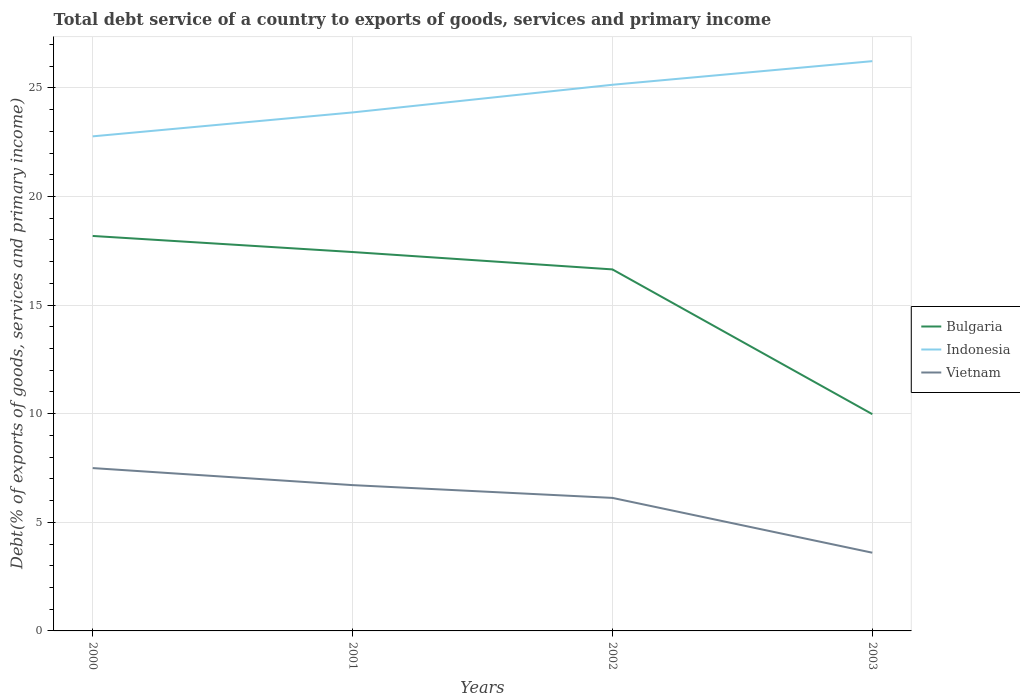How many different coloured lines are there?
Provide a succinct answer. 3. Across all years, what is the maximum total debt service in Vietnam?
Your answer should be very brief. 3.6. In which year was the total debt service in Bulgaria maximum?
Your answer should be very brief. 2003. What is the total total debt service in Vietnam in the graph?
Provide a short and direct response. 2.52. What is the difference between the highest and the second highest total debt service in Vietnam?
Give a very brief answer. 3.9. Is the total debt service in Bulgaria strictly greater than the total debt service in Vietnam over the years?
Provide a succinct answer. No. How many lines are there?
Make the answer very short. 3. How many years are there in the graph?
Your answer should be compact. 4. Are the values on the major ticks of Y-axis written in scientific E-notation?
Ensure brevity in your answer.  No. How many legend labels are there?
Offer a terse response. 3. How are the legend labels stacked?
Ensure brevity in your answer.  Vertical. What is the title of the graph?
Your answer should be compact. Total debt service of a country to exports of goods, services and primary income. Does "Gambia, The" appear as one of the legend labels in the graph?
Your response must be concise. No. What is the label or title of the X-axis?
Offer a terse response. Years. What is the label or title of the Y-axis?
Make the answer very short. Debt(% of exports of goods, services and primary income). What is the Debt(% of exports of goods, services and primary income) in Bulgaria in 2000?
Your answer should be compact. 18.18. What is the Debt(% of exports of goods, services and primary income) of Indonesia in 2000?
Your response must be concise. 22.77. What is the Debt(% of exports of goods, services and primary income) in Vietnam in 2000?
Make the answer very short. 7.5. What is the Debt(% of exports of goods, services and primary income) in Bulgaria in 2001?
Give a very brief answer. 17.44. What is the Debt(% of exports of goods, services and primary income) in Indonesia in 2001?
Keep it short and to the point. 23.87. What is the Debt(% of exports of goods, services and primary income) in Vietnam in 2001?
Your answer should be very brief. 6.71. What is the Debt(% of exports of goods, services and primary income) of Bulgaria in 2002?
Make the answer very short. 16.64. What is the Debt(% of exports of goods, services and primary income) in Indonesia in 2002?
Your answer should be compact. 25.14. What is the Debt(% of exports of goods, services and primary income) in Vietnam in 2002?
Your answer should be compact. 6.12. What is the Debt(% of exports of goods, services and primary income) in Bulgaria in 2003?
Ensure brevity in your answer.  9.98. What is the Debt(% of exports of goods, services and primary income) of Indonesia in 2003?
Your response must be concise. 26.23. What is the Debt(% of exports of goods, services and primary income) in Vietnam in 2003?
Keep it short and to the point. 3.6. Across all years, what is the maximum Debt(% of exports of goods, services and primary income) in Bulgaria?
Offer a very short reply. 18.18. Across all years, what is the maximum Debt(% of exports of goods, services and primary income) of Indonesia?
Your answer should be very brief. 26.23. Across all years, what is the maximum Debt(% of exports of goods, services and primary income) in Vietnam?
Your response must be concise. 7.5. Across all years, what is the minimum Debt(% of exports of goods, services and primary income) in Bulgaria?
Make the answer very short. 9.98. Across all years, what is the minimum Debt(% of exports of goods, services and primary income) of Indonesia?
Your answer should be very brief. 22.77. Across all years, what is the minimum Debt(% of exports of goods, services and primary income) of Vietnam?
Your response must be concise. 3.6. What is the total Debt(% of exports of goods, services and primary income) in Bulgaria in the graph?
Your answer should be compact. 62.24. What is the total Debt(% of exports of goods, services and primary income) of Indonesia in the graph?
Your answer should be compact. 98. What is the total Debt(% of exports of goods, services and primary income) of Vietnam in the graph?
Your answer should be compact. 23.93. What is the difference between the Debt(% of exports of goods, services and primary income) in Bulgaria in 2000 and that in 2001?
Your response must be concise. 0.74. What is the difference between the Debt(% of exports of goods, services and primary income) of Indonesia in 2000 and that in 2001?
Your answer should be very brief. -1.1. What is the difference between the Debt(% of exports of goods, services and primary income) in Vietnam in 2000 and that in 2001?
Keep it short and to the point. 0.78. What is the difference between the Debt(% of exports of goods, services and primary income) in Bulgaria in 2000 and that in 2002?
Keep it short and to the point. 1.54. What is the difference between the Debt(% of exports of goods, services and primary income) in Indonesia in 2000 and that in 2002?
Give a very brief answer. -2.38. What is the difference between the Debt(% of exports of goods, services and primary income) of Vietnam in 2000 and that in 2002?
Make the answer very short. 1.37. What is the difference between the Debt(% of exports of goods, services and primary income) in Bulgaria in 2000 and that in 2003?
Keep it short and to the point. 8.2. What is the difference between the Debt(% of exports of goods, services and primary income) in Indonesia in 2000 and that in 2003?
Give a very brief answer. -3.46. What is the difference between the Debt(% of exports of goods, services and primary income) of Vietnam in 2000 and that in 2003?
Make the answer very short. 3.9. What is the difference between the Debt(% of exports of goods, services and primary income) of Bulgaria in 2001 and that in 2002?
Offer a terse response. 0.8. What is the difference between the Debt(% of exports of goods, services and primary income) of Indonesia in 2001 and that in 2002?
Provide a succinct answer. -1.27. What is the difference between the Debt(% of exports of goods, services and primary income) in Vietnam in 2001 and that in 2002?
Your response must be concise. 0.59. What is the difference between the Debt(% of exports of goods, services and primary income) of Bulgaria in 2001 and that in 2003?
Provide a short and direct response. 7.46. What is the difference between the Debt(% of exports of goods, services and primary income) in Indonesia in 2001 and that in 2003?
Your answer should be compact. -2.36. What is the difference between the Debt(% of exports of goods, services and primary income) of Vietnam in 2001 and that in 2003?
Your answer should be compact. 3.11. What is the difference between the Debt(% of exports of goods, services and primary income) in Bulgaria in 2002 and that in 2003?
Ensure brevity in your answer.  6.66. What is the difference between the Debt(% of exports of goods, services and primary income) of Indonesia in 2002 and that in 2003?
Your answer should be compact. -1.09. What is the difference between the Debt(% of exports of goods, services and primary income) of Vietnam in 2002 and that in 2003?
Ensure brevity in your answer.  2.52. What is the difference between the Debt(% of exports of goods, services and primary income) of Bulgaria in 2000 and the Debt(% of exports of goods, services and primary income) of Indonesia in 2001?
Offer a terse response. -5.69. What is the difference between the Debt(% of exports of goods, services and primary income) in Bulgaria in 2000 and the Debt(% of exports of goods, services and primary income) in Vietnam in 2001?
Give a very brief answer. 11.47. What is the difference between the Debt(% of exports of goods, services and primary income) of Indonesia in 2000 and the Debt(% of exports of goods, services and primary income) of Vietnam in 2001?
Offer a very short reply. 16.05. What is the difference between the Debt(% of exports of goods, services and primary income) in Bulgaria in 2000 and the Debt(% of exports of goods, services and primary income) in Indonesia in 2002?
Provide a succinct answer. -6.96. What is the difference between the Debt(% of exports of goods, services and primary income) in Bulgaria in 2000 and the Debt(% of exports of goods, services and primary income) in Vietnam in 2002?
Your answer should be compact. 12.06. What is the difference between the Debt(% of exports of goods, services and primary income) in Indonesia in 2000 and the Debt(% of exports of goods, services and primary income) in Vietnam in 2002?
Make the answer very short. 16.64. What is the difference between the Debt(% of exports of goods, services and primary income) of Bulgaria in 2000 and the Debt(% of exports of goods, services and primary income) of Indonesia in 2003?
Provide a short and direct response. -8.05. What is the difference between the Debt(% of exports of goods, services and primary income) in Bulgaria in 2000 and the Debt(% of exports of goods, services and primary income) in Vietnam in 2003?
Make the answer very short. 14.58. What is the difference between the Debt(% of exports of goods, services and primary income) of Indonesia in 2000 and the Debt(% of exports of goods, services and primary income) of Vietnam in 2003?
Provide a short and direct response. 19.17. What is the difference between the Debt(% of exports of goods, services and primary income) in Bulgaria in 2001 and the Debt(% of exports of goods, services and primary income) in Indonesia in 2002?
Give a very brief answer. -7.7. What is the difference between the Debt(% of exports of goods, services and primary income) in Bulgaria in 2001 and the Debt(% of exports of goods, services and primary income) in Vietnam in 2002?
Keep it short and to the point. 11.32. What is the difference between the Debt(% of exports of goods, services and primary income) in Indonesia in 2001 and the Debt(% of exports of goods, services and primary income) in Vietnam in 2002?
Provide a short and direct response. 17.74. What is the difference between the Debt(% of exports of goods, services and primary income) in Bulgaria in 2001 and the Debt(% of exports of goods, services and primary income) in Indonesia in 2003?
Make the answer very short. -8.79. What is the difference between the Debt(% of exports of goods, services and primary income) of Bulgaria in 2001 and the Debt(% of exports of goods, services and primary income) of Vietnam in 2003?
Your response must be concise. 13.84. What is the difference between the Debt(% of exports of goods, services and primary income) of Indonesia in 2001 and the Debt(% of exports of goods, services and primary income) of Vietnam in 2003?
Provide a succinct answer. 20.27. What is the difference between the Debt(% of exports of goods, services and primary income) in Bulgaria in 2002 and the Debt(% of exports of goods, services and primary income) in Indonesia in 2003?
Offer a very short reply. -9.59. What is the difference between the Debt(% of exports of goods, services and primary income) of Bulgaria in 2002 and the Debt(% of exports of goods, services and primary income) of Vietnam in 2003?
Keep it short and to the point. 13.04. What is the difference between the Debt(% of exports of goods, services and primary income) of Indonesia in 2002 and the Debt(% of exports of goods, services and primary income) of Vietnam in 2003?
Provide a short and direct response. 21.54. What is the average Debt(% of exports of goods, services and primary income) in Bulgaria per year?
Offer a very short reply. 15.56. What is the average Debt(% of exports of goods, services and primary income) in Indonesia per year?
Keep it short and to the point. 24.5. What is the average Debt(% of exports of goods, services and primary income) of Vietnam per year?
Give a very brief answer. 5.98. In the year 2000, what is the difference between the Debt(% of exports of goods, services and primary income) in Bulgaria and Debt(% of exports of goods, services and primary income) in Indonesia?
Your answer should be compact. -4.58. In the year 2000, what is the difference between the Debt(% of exports of goods, services and primary income) of Bulgaria and Debt(% of exports of goods, services and primary income) of Vietnam?
Provide a succinct answer. 10.69. In the year 2000, what is the difference between the Debt(% of exports of goods, services and primary income) in Indonesia and Debt(% of exports of goods, services and primary income) in Vietnam?
Provide a succinct answer. 15.27. In the year 2001, what is the difference between the Debt(% of exports of goods, services and primary income) of Bulgaria and Debt(% of exports of goods, services and primary income) of Indonesia?
Your answer should be compact. -6.43. In the year 2001, what is the difference between the Debt(% of exports of goods, services and primary income) of Bulgaria and Debt(% of exports of goods, services and primary income) of Vietnam?
Keep it short and to the point. 10.73. In the year 2001, what is the difference between the Debt(% of exports of goods, services and primary income) in Indonesia and Debt(% of exports of goods, services and primary income) in Vietnam?
Ensure brevity in your answer.  17.16. In the year 2002, what is the difference between the Debt(% of exports of goods, services and primary income) of Bulgaria and Debt(% of exports of goods, services and primary income) of Vietnam?
Keep it short and to the point. 10.52. In the year 2002, what is the difference between the Debt(% of exports of goods, services and primary income) of Indonesia and Debt(% of exports of goods, services and primary income) of Vietnam?
Offer a terse response. 19.02. In the year 2003, what is the difference between the Debt(% of exports of goods, services and primary income) in Bulgaria and Debt(% of exports of goods, services and primary income) in Indonesia?
Your answer should be very brief. -16.25. In the year 2003, what is the difference between the Debt(% of exports of goods, services and primary income) of Bulgaria and Debt(% of exports of goods, services and primary income) of Vietnam?
Ensure brevity in your answer.  6.38. In the year 2003, what is the difference between the Debt(% of exports of goods, services and primary income) in Indonesia and Debt(% of exports of goods, services and primary income) in Vietnam?
Provide a succinct answer. 22.63. What is the ratio of the Debt(% of exports of goods, services and primary income) in Bulgaria in 2000 to that in 2001?
Offer a very short reply. 1.04. What is the ratio of the Debt(% of exports of goods, services and primary income) in Indonesia in 2000 to that in 2001?
Provide a short and direct response. 0.95. What is the ratio of the Debt(% of exports of goods, services and primary income) of Vietnam in 2000 to that in 2001?
Make the answer very short. 1.12. What is the ratio of the Debt(% of exports of goods, services and primary income) in Bulgaria in 2000 to that in 2002?
Keep it short and to the point. 1.09. What is the ratio of the Debt(% of exports of goods, services and primary income) of Indonesia in 2000 to that in 2002?
Keep it short and to the point. 0.91. What is the ratio of the Debt(% of exports of goods, services and primary income) of Vietnam in 2000 to that in 2002?
Your response must be concise. 1.22. What is the ratio of the Debt(% of exports of goods, services and primary income) in Bulgaria in 2000 to that in 2003?
Your answer should be very brief. 1.82. What is the ratio of the Debt(% of exports of goods, services and primary income) of Indonesia in 2000 to that in 2003?
Your answer should be very brief. 0.87. What is the ratio of the Debt(% of exports of goods, services and primary income) of Vietnam in 2000 to that in 2003?
Your answer should be compact. 2.08. What is the ratio of the Debt(% of exports of goods, services and primary income) in Bulgaria in 2001 to that in 2002?
Keep it short and to the point. 1.05. What is the ratio of the Debt(% of exports of goods, services and primary income) in Indonesia in 2001 to that in 2002?
Your answer should be very brief. 0.95. What is the ratio of the Debt(% of exports of goods, services and primary income) of Vietnam in 2001 to that in 2002?
Your answer should be compact. 1.1. What is the ratio of the Debt(% of exports of goods, services and primary income) in Bulgaria in 2001 to that in 2003?
Provide a short and direct response. 1.75. What is the ratio of the Debt(% of exports of goods, services and primary income) of Indonesia in 2001 to that in 2003?
Your answer should be compact. 0.91. What is the ratio of the Debt(% of exports of goods, services and primary income) of Vietnam in 2001 to that in 2003?
Keep it short and to the point. 1.86. What is the ratio of the Debt(% of exports of goods, services and primary income) of Bulgaria in 2002 to that in 2003?
Offer a terse response. 1.67. What is the ratio of the Debt(% of exports of goods, services and primary income) of Indonesia in 2002 to that in 2003?
Provide a short and direct response. 0.96. What is the ratio of the Debt(% of exports of goods, services and primary income) in Vietnam in 2002 to that in 2003?
Your response must be concise. 1.7. What is the difference between the highest and the second highest Debt(% of exports of goods, services and primary income) of Bulgaria?
Offer a terse response. 0.74. What is the difference between the highest and the second highest Debt(% of exports of goods, services and primary income) in Indonesia?
Your answer should be very brief. 1.09. What is the difference between the highest and the second highest Debt(% of exports of goods, services and primary income) of Vietnam?
Your answer should be very brief. 0.78. What is the difference between the highest and the lowest Debt(% of exports of goods, services and primary income) in Bulgaria?
Keep it short and to the point. 8.2. What is the difference between the highest and the lowest Debt(% of exports of goods, services and primary income) of Indonesia?
Your answer should be very brief. 3.46. What is the difference between the highest and the lowest Debt(% of exports of goods, services and primary income) in Vietnam?
Make the answer very short. 3.9. 